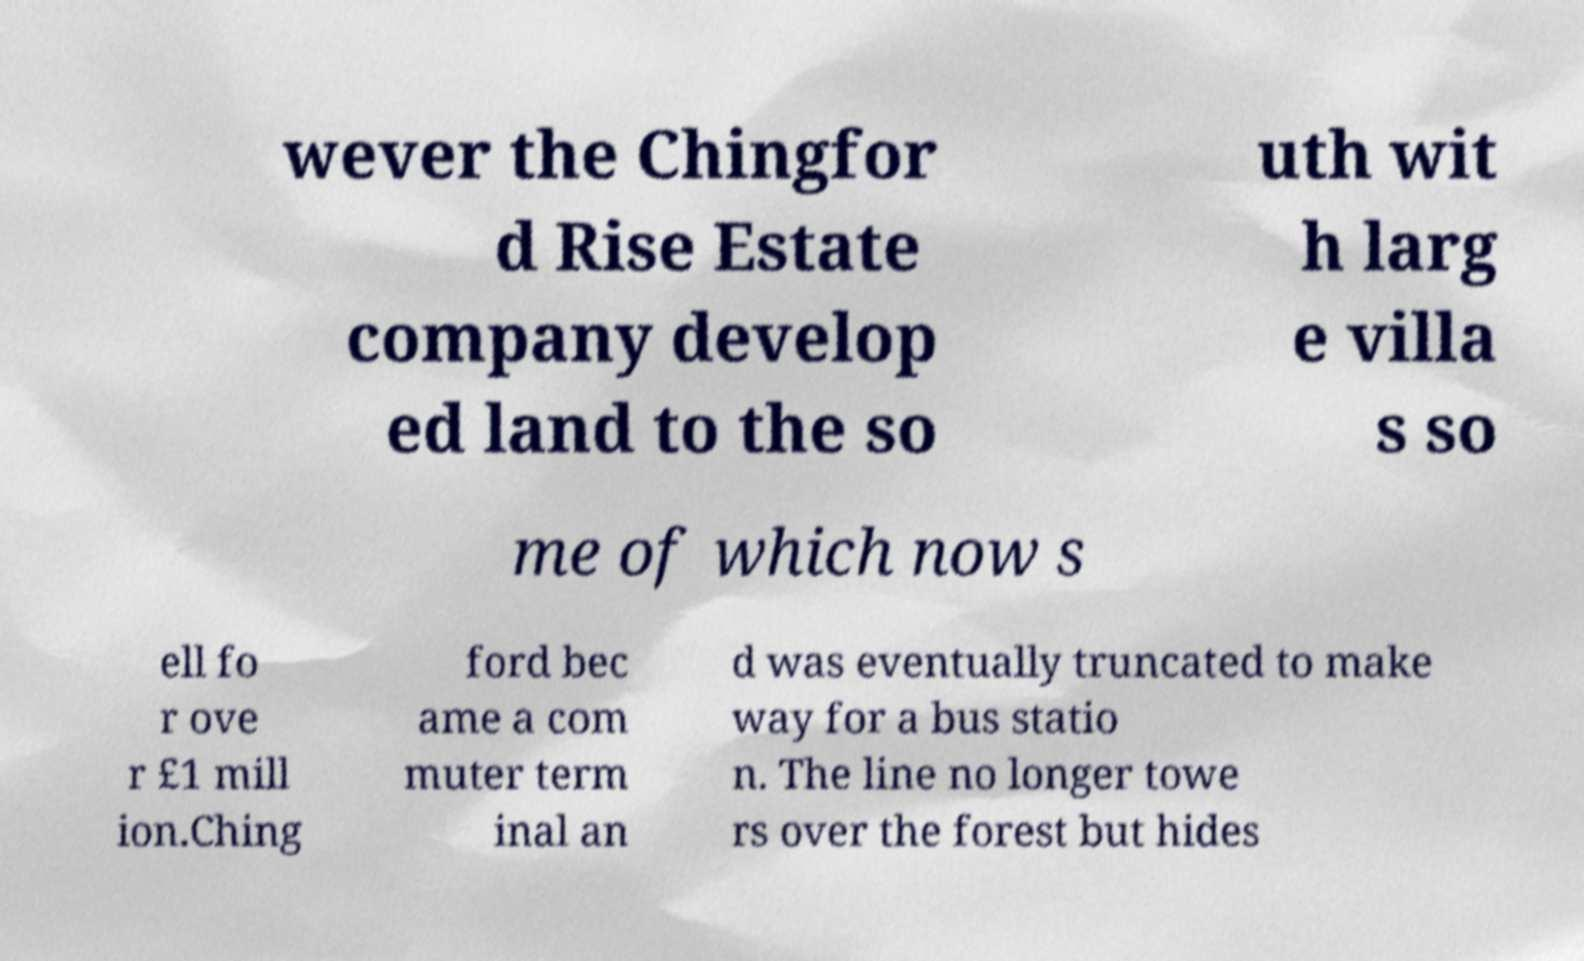What messages or text are displayed in this image? I need them in a readable, typed format. wever the Chingfor d Rise Estate company develop ed land to the so uth wit h larg e villa s so me of which now s ell fo r ove r £1 mill ion.Ching ford bec ame a com muter term inal an d was eventually truncated to make way for a bus statio n. The line no longer towe rs over the forest but hides 